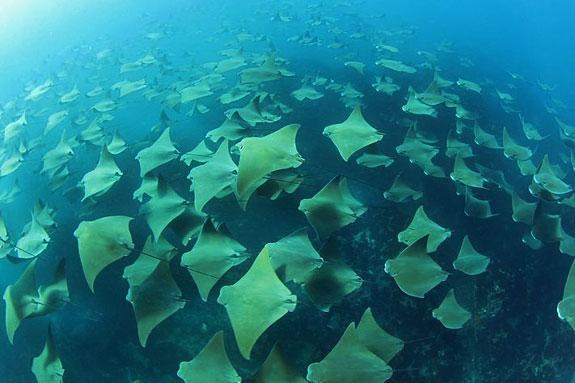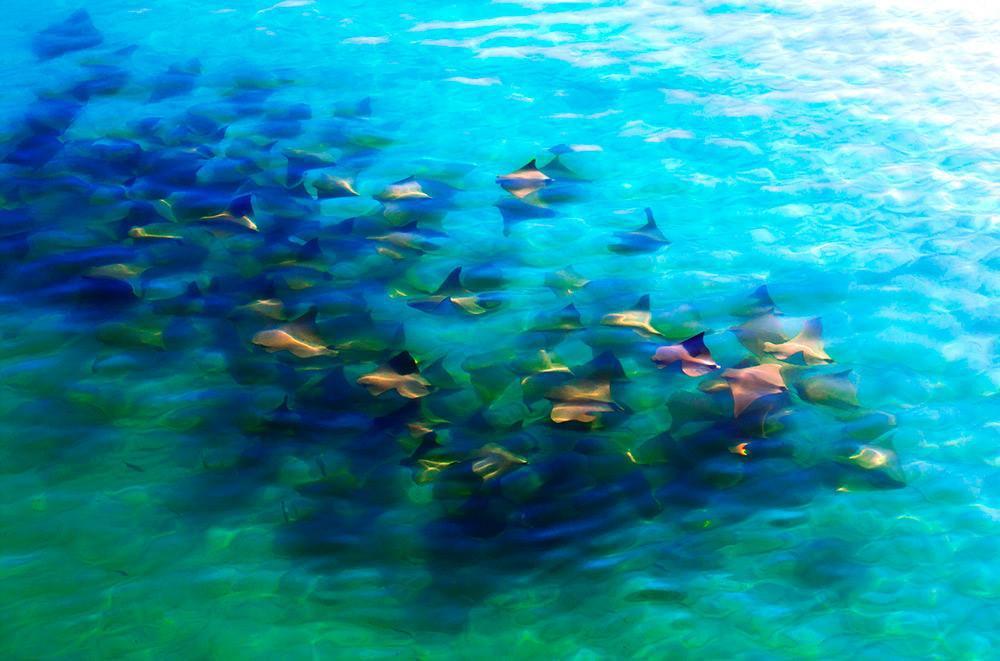The first image is the image on the left, the second image is the image on the right. Considering the images on both sides, is "There are no more than eight creatures in the image on the right." valid? Answer yes or no. No. 